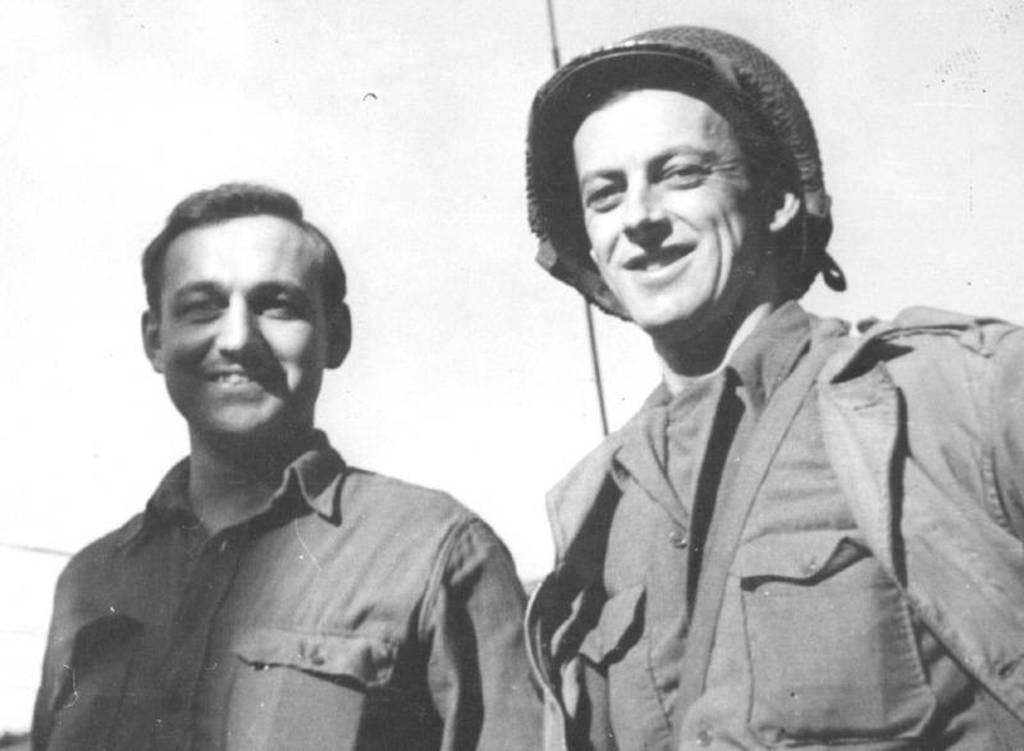How many people are in the image? There are two men in the image. What are the men doing in the image? Both men are standing. What expression do the men have in the image? The men are smiling. What is the man on the right wearing? The man on the right is wearing a helmet. What color is the background of the image? The background of the image is white. Are there any chairs visible in the image? There are no chairs present in the image. Can you see any dust or ants in the image? There is no dust or ants visible in the image. 